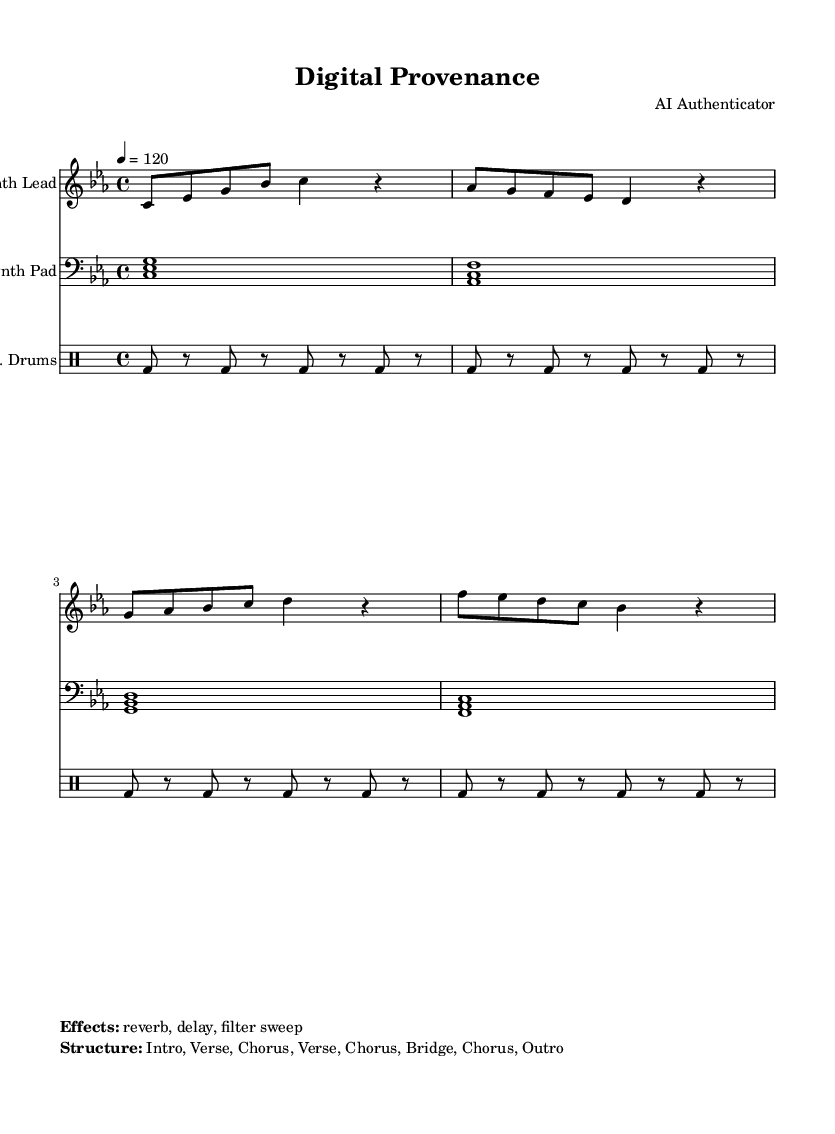What is the key signature of this music? The key signature is C minor, indicated by three flat notes (B♭, E♭, and A♭) in the upper left corner of the sheet music.
Answer: C minor What is the time signature of this music? The time signature is 4/4, which is shown in the upper left area of the sheet music, meaning there are four beats per measure.
Answer: 4/4 What is the tempo marking for this piece? The tempo marking indicates that the piece should be played at a speed of 120 beats per minute, found next to the tempo indication in the sheet music.
Answer: 120 How many distinct sections are present in the song structure? The structure includes seven sections: Intro, Verse, Chorus, Verse, Chorus, Bridge, and Chorus, listed under the "Effects" section in the markup.
Answer: 7 What types of instruments are used in the score? The score features a "Synth Lead," "Synth Pad," and "E. Drums," each shown under their respective staff lines in the sheet music.
Answer: Synth Lead, Synth Pad, E. Drums Which special effects are indicated in the markup? The markup lists three effects: reverb, delay, and filter sweep, specifically mentioned under the "Effects" section.
Answer: Reverb, delay, filter sweep 